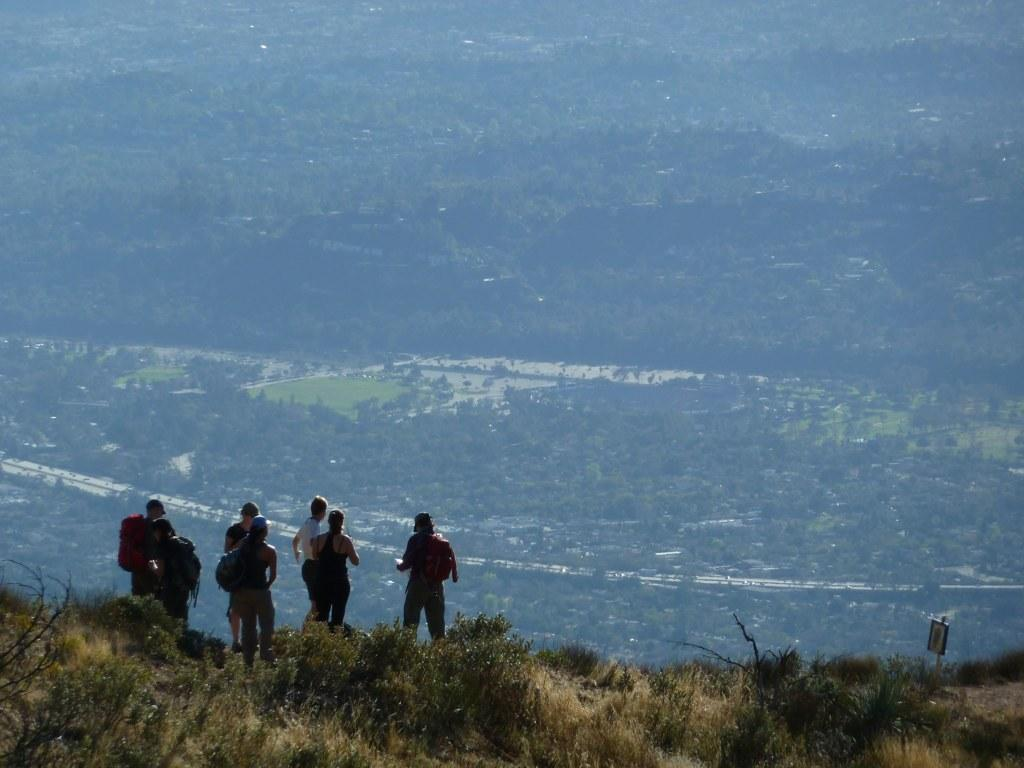How many people are in the image? There is a group of people standing in the image, but the exact number cannot be determined from the provided facts. What type of vegetation is visible in the image? Plants, grass, and trees are visible in the image. Can you describe the background of the image? The background of the image includes trees. What type of wire is holding the frame in the image? There is no wire or frame present in the image. Can you describe the behavior of the rat in the image? There is no rat present in the image. 